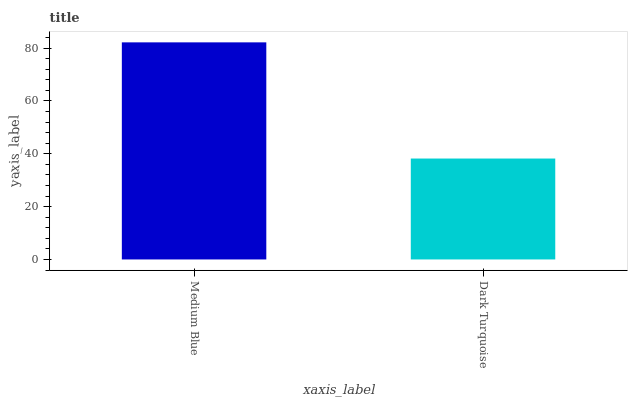Is Dark Turquoise the minimum?
Answer yes or no. Yes. Is Medium Blue the maximum?
Answer yes or no. Yes. Is Dark Turquoise the maximum?
Answer yes or no. No. Is Medium Blue greater than Dark Turquoise?
Answer yes or no. Yes. Is Dark Turquoise less than Medium Blue?
Answer yes or no. Yes. Is Dark Turquoise greater than Medium Blue?
Answer yes or no. No. Is Medium Blue less than Dark Turquoise?
Answer yes or no. No. Is Medium Blue the high median?
Answer yes or no. Yes. Is Dark Turquoise the low median?
Answer yes or no. Yes. Is Dark Turquoise the high median?
Answer yes or no. No. Is Medium Blue the low median?
Answer yes or no. No. 